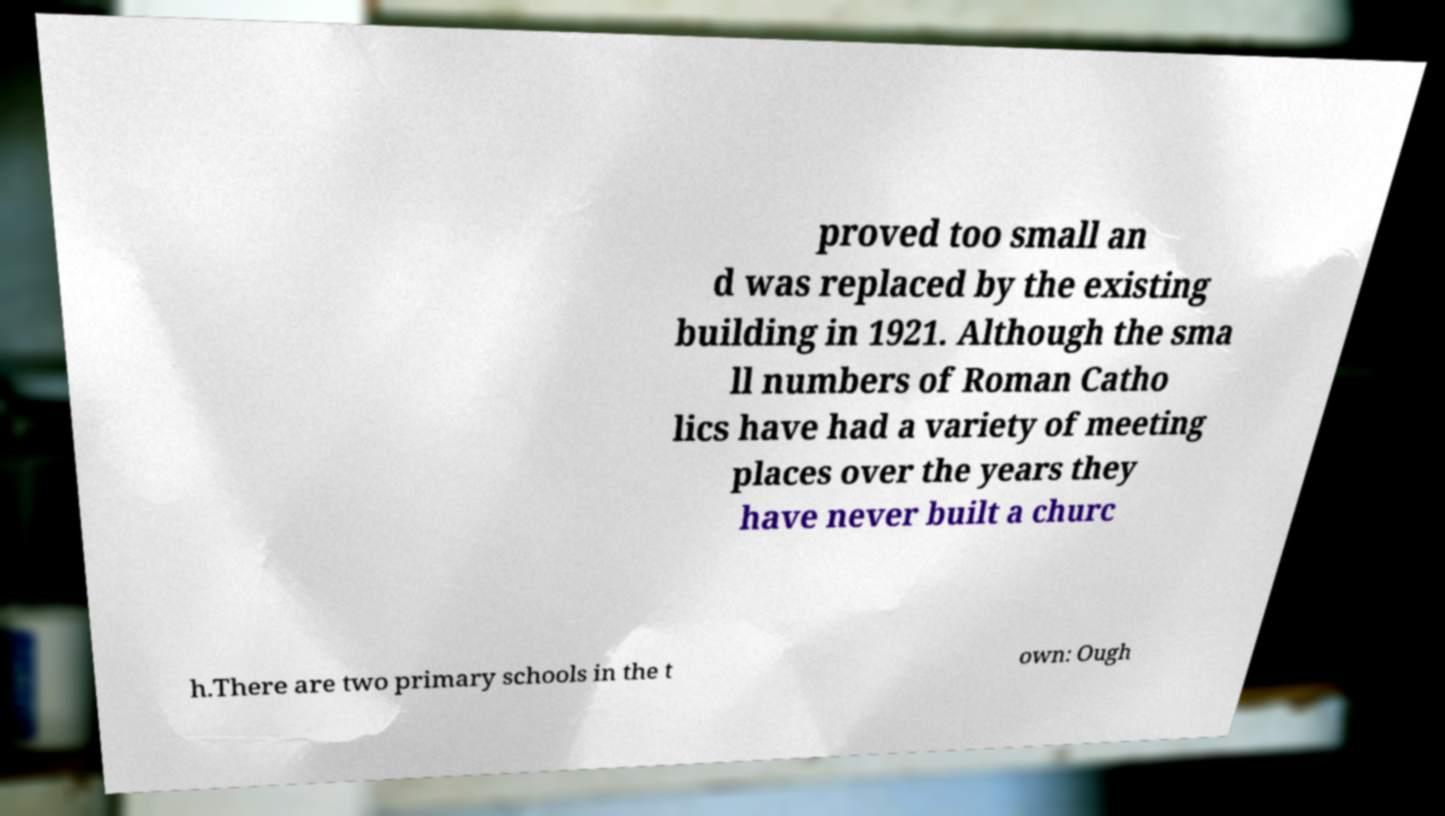There's text embedded in this image that I need extracted. Can you transcribe it verbatim? proved too small an d was replaced by the existing building in 1921. Although the sma ll numbers of Roman Catho lics have had a variety of meeting places over the years they have never built a churc h.There are two primary schools in the t own: Ough 